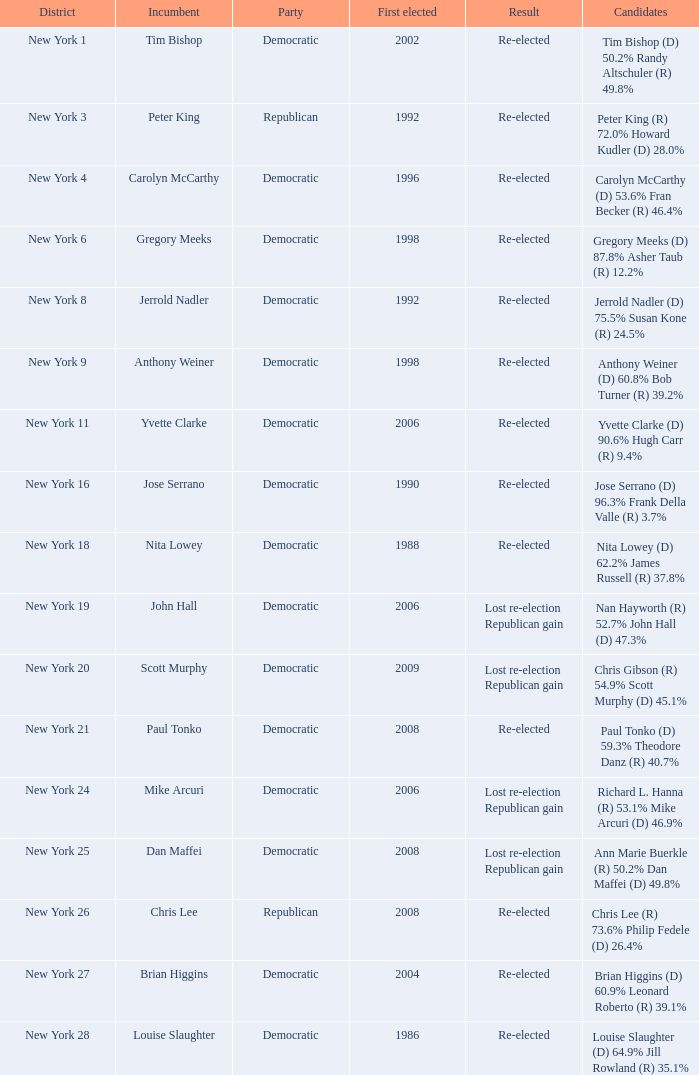Indicate the event for new york 4 Democratic. Could you help me parse every detail presented in this table? {'header': ['District', 'Incumbent', 'Party', 'First elected', 'Result', 'Candidates'], 'rows': [['New York 1', 'Tim Bishop', 'Democratic', '2002', 'Re-elected', 'Tim Bishop (D) 50.2% Randy Altschuler (R) 49.8%'], ['New York 3', 'Peter King', 'Republican', '1992', 'Re-elected', 'Peter King (R) 72.0% Howard Kudler (D) 28.0%'], ['New York 4', 'Carolyn McCarthy', 'Democratic', '1996', 'Re-elected', 'Carolyn McCarthy (D) 53.6% Fran Becker (R) 46.4%'], ['New York 6', 'Gregory Meeks', 'Democratic', '1998', 'Re-elected', 'Gregory Meeks (D) 87.8% Asher Taub (R) 12.2%'], ['New York 8', 'Jerrold Nadler', 'Democratic', '1992', 'Re-elected', 'Jerrold Nadler (D) 75.5% Susan Kone (R) 24.5%'], ['New York 9', 'Anthony Weiner', 'Democratic', '1998', 'Re-elected', 'Anthony Weiner (D) 60.8% Bob Turner (R) 39.2%'], ['New York 11', 'Yvette Clarke', 'Democratic', '2006', 'Re-elected', 'Yvette Clarke (D) 90.6% Hugh Carr (R) 9.4%'], ['New York 16', 'Jose Serrano', 'Democratic', '1990', 'Re-elected', 'Jose Serrano (D) 96.3% Frank Della Valle (R) 3.7%'], ['New York 18', 'Nita Lowey', 'Democratic', '1988', 'Re-elected', 'Nita Lowey (D) 62.2% James Russell (R) 37.8%'], ['New York 19', 'John Hall', 'Democratic', '2006', 'Lost re-election Republican gain', 'Nan Hayworth (R) 52.7% John Hall (D) 47.3%'], ['New York 20', 'Scott Murphy', 'Democratic', '2009', 'Lost re-election Republican gain', 'Chris Gibson (R) 54.9% Scott Murphy (D) 45.1%'], ['New York 21', 'Paul Tonko', 'Democratic', '2008', 'Re-elected', 'Paul Tonko (D) 59.3% Theodore Danz (R) 40.7%'], ['New York 24', 'Mike Arcuri', 'Democratic', '2006', 'Lost re-election Republican gain', 'Richard L. Hanna (R) 53.1% Mike Arcuri (D) 46.9%'], ['New York 25', 'Dan Maffei', 'Democratic', '2008', 'Lost re-election Republican gain', 'Ann Marie Buerkle (R) 50.2% Dan Maffei (D) 49.8%'], ['New York 26', 'Chris Lee', 'Republican', '2008', 'Re-elected', 'Chris Lee (R) 73.6% Philip Fedele (D) 26.4%'], ['New York 27', 'Brian Higgins', 'Democratic', '2004', 'Re-elected', 'Brian Higgins (D) 60.9% Leonard Roberto (R) 39.1%'], ['New York 28', 'Louise Slaughter', 'Democratic', '1986', 'Re-elected', 'Louise Slaughter (D) 64.9% Jill Rowland (R) 35.1%']]} 